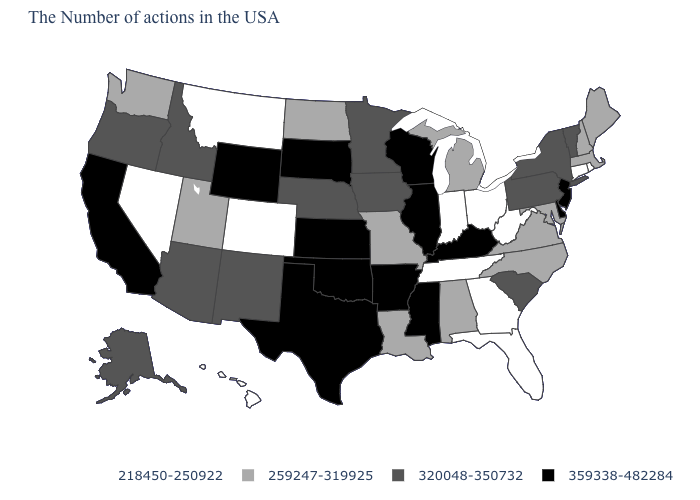What is the value of Rhode Island?
Keep it brief. 218450-250922. Which states have the lowest value in the USA?
Concise answer only. Rhode Island, Connecticut, West Virginia, Ohio, Florida, Georgia, Indiana, Tennessee, Colorado, Montana, Nevada, Hawaii. What is the value of Utah?
Answer briefly. 259247-319925. What is the value of Kentucky?
Write a very short answer. 359338-482284. What is the value of South Dakota?
Give a very brief answer. 359338-482284. Name the states that have a value in the range 359338-482284?
Keep it brief. New Jersey, Delaware, Kentucky, Wisconsin, Illinois, Mississippi, Arkansas, Kansas, Oklahoma, Texas, South Dakota, Wyoming, California. Does the first symbol in the legend represent the smallest category?
Answer briefly. Yes. Name the states that have a value in the range 218450-250922?
Keep it brief. Rhode Island, Connecticut, West Virginia, Ohio, Florida, Georgia, Indiana, Tennessee, Colorado, Montana, Nevada, Hawaii. What is the value of Kansas?
Quick response, please. 359338-482284. Name the states that have a value in the range 218450-250922?
Answer briefly. Rhode Island, Connecticut, West Virginia, Ohio, Florida, Georgia, Indiana, Tennessee, Colorado, Montana, Nevada, Hawaii. Name the states that have a value in the range 259247-319925?
Answer briefly. Maine, Massachusetts, New Hampshire, Maryland, Virginia, North Carolina, Michigan, Alabama, Louisiana, Missouri, North Dakota, Utah, Washington. What is the highest value in states that border Rhode Island?
Keep it brief. 259247-319925. Is the legend a continuous bar?
Give a very brief answer. No. What is the value of Arizona?
Answer briefly. 320048-350732. What is the value of New Jersey?
Answer briefly. 359338-482284. 